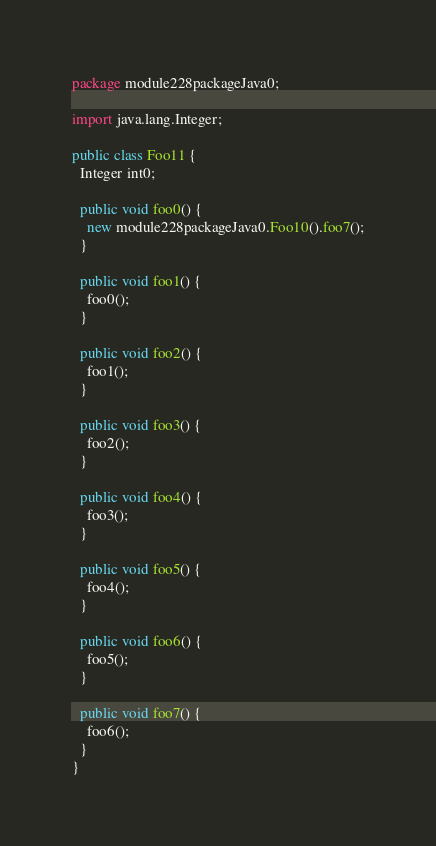<code> <loc_0><loc_0><loc_500><loc_500><_Java_>package module228packageJava0;

import java.lang.Integer;

public class Foo11 {
  Integer int0;

  public void foo0() {
    new module228packageJava0.Foo10().foo7();
  }

  public void foo1() {
    foo0();
  }

  public void foo2() {
    foo1();
  }

  public void foo3() {
    foo2();
  }

  public void foo4() {
    foo3();
  }

  public void foo5() {
    foo4();
  }

  public void foo6() {
    foo5();
  }

  public void foo7() {
    foo6();
  }
}
</code> 